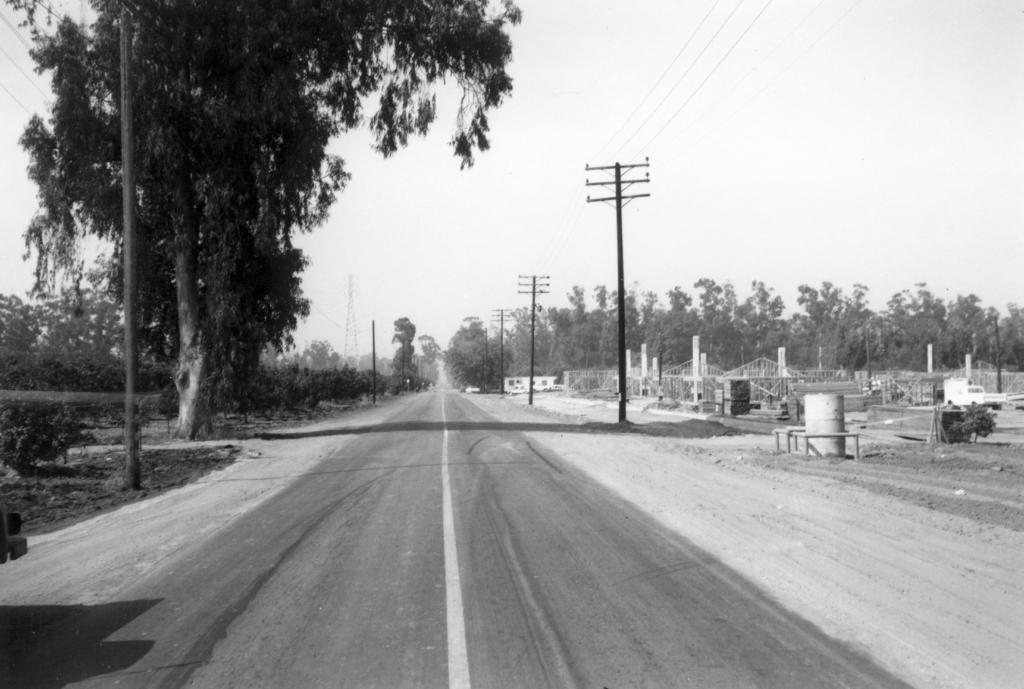Could you give a brief overview of what you see in this image? This picture shows trees, poles and electrical poles and we see a road and plants on the ground and a cloudy sky. 